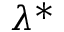Convert formula to latex. <formula><loc_0><loc_0><loc_500><loc_500>\, \lambda ^ { * }</formula> 